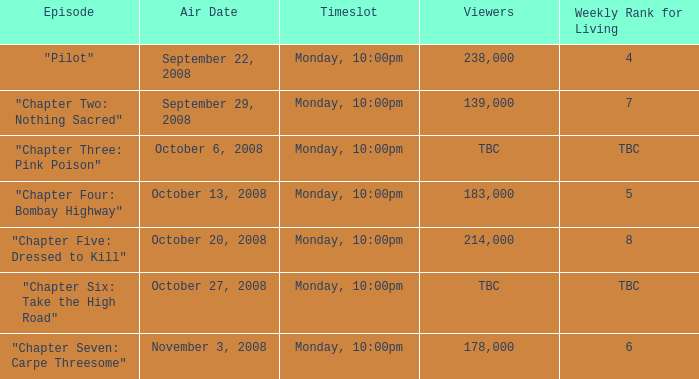How many spectators watched the episode with a living weekly rank of 4? 238000.0. 